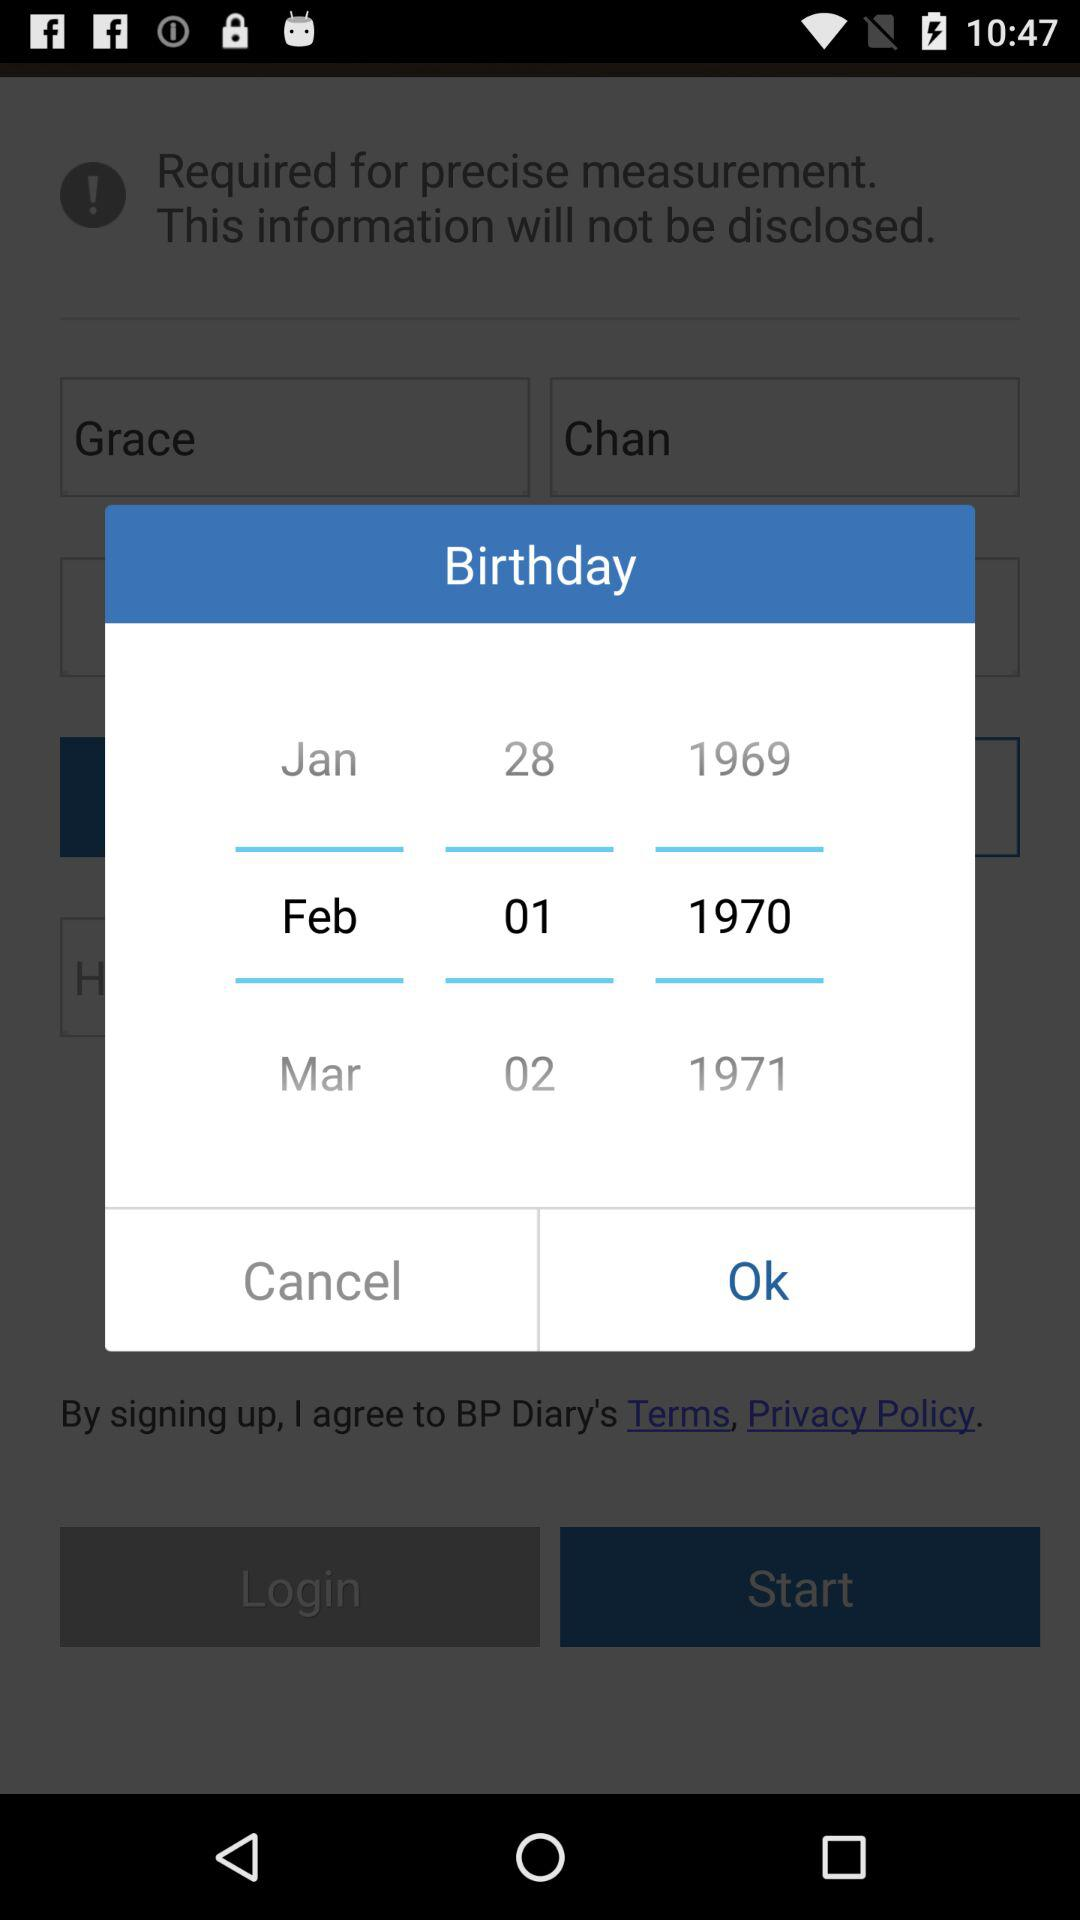What is the selected birthdate? The birthdate is February 1, 1970. 